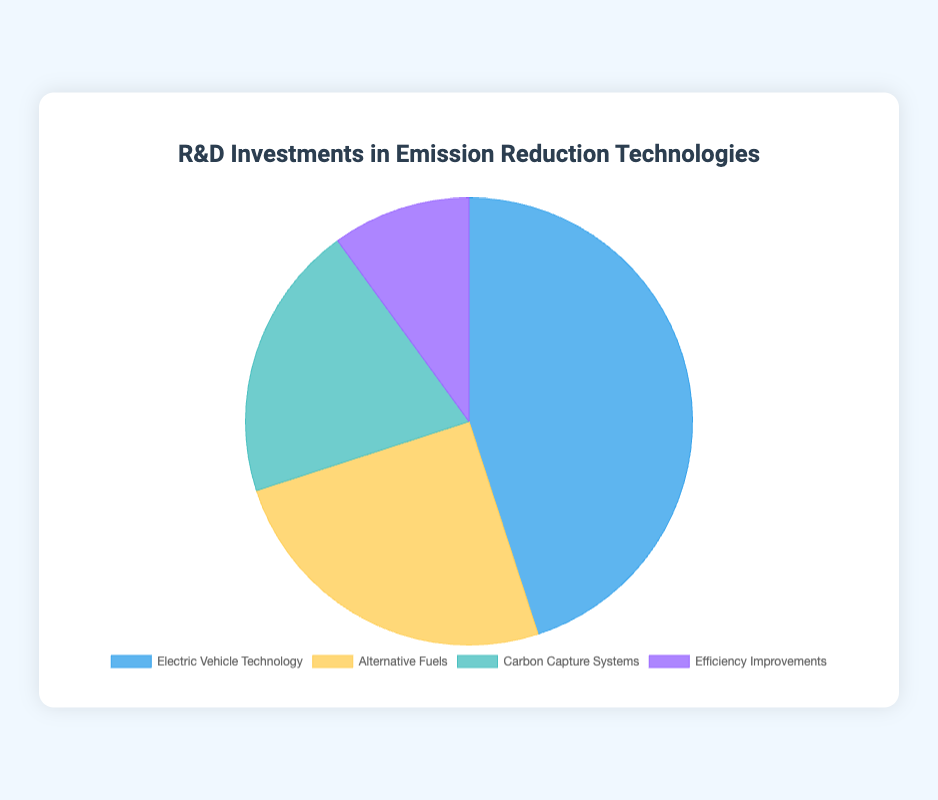Which technology received the highest investment? The pie chart shows the percentage investments in various technologies. The slice labeled "Electric Vehicle Technology" is the largest, indicating it received the most investment.
Answer: Electric Vehicle Technology Which two technologies received a combined investment of 70%? By looking at the pie chart and summing the percentages, "Electric Vehicle Technology" (45%) and "Alternative Fuels" (25%) together make up 70%.
Answer: Electric Vehicle Technology and Alternative Fuels How does the investment in Efficiency Improvements compare to Carbon Capture Systems? The pie chart shows that Efficiency Improvements received 10% while Carbon Capture Systems received 20%. Therefore, Carbon Capture Systems received double the investment of Efficiency Improvements.
Answer: Carbon Capture Systems received double the investment of Efficiency Improvements What percentage of total investment is allocated to technologies other than Electric Vehicle Technology? The slice for Electric Vehicle Technology represents 45%, so the remaining investment is 100% - 45% = 55% for the other technologies combined.
Answer: 55% If we combine the investments in Alternative Fuels and Efficiency Improvements, do they surpass the investment in Electric Vehicle Technology? Adding Alternative Fuels (25%) and Efficiency Improvements (10%) gives 35%. Since 35% is less than 45%, they do not surpass the investment in Electric Vehicle Technology.
Answer: No Which category has the smallest portion of the pie chart, and what companies are associated with it? The smallest slice in the pie chart corresponds to "Efficiency Improvements" with 10%, and it lists companies such as Honeywell, Siemens, GE, and Schneider Electric.
Answer: Efficiency Improvements, Honeywell, Siemens, GE, Schneider Electric What is the total investment percentage of Carbon Capture Systems and Electric Vehicle Technology together? The pie chart indicates Carbon Capture Systems at 20% and Electric Vehicle Technology at 45%. Together, these categories make up 20% + 45% = 65%.
Answer: 65% Which slice in the pie chart is yellow, and what fraction of the investments does it represent? The yellow slice in the pie chart represents "Alternative Fuels," which makes up 25% of the investments.
Answer: Alternative Fuels, 25% 